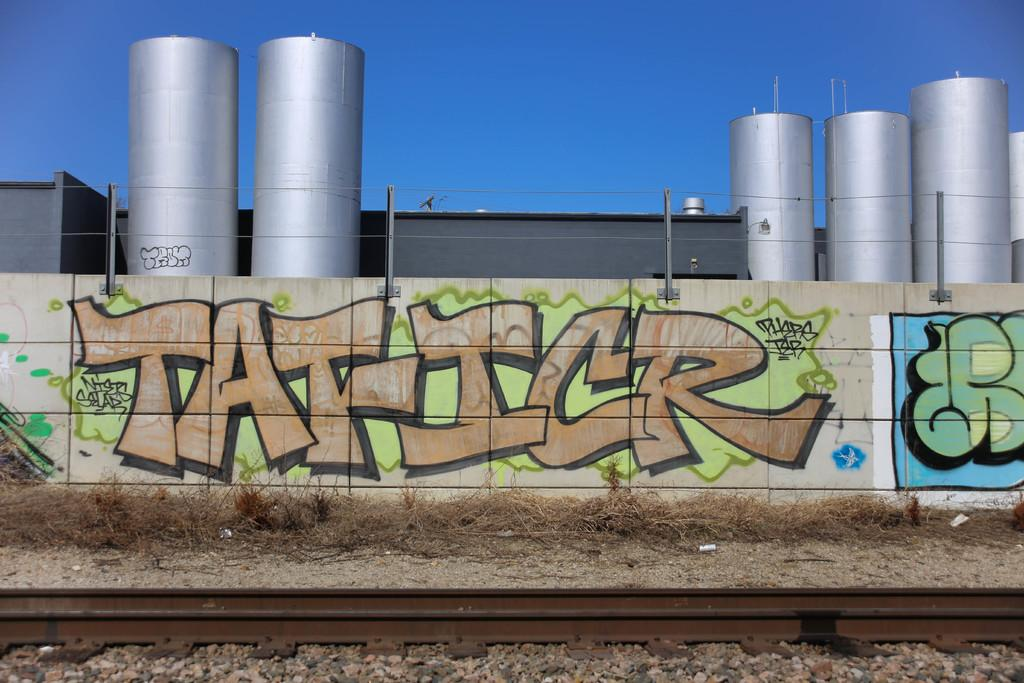Provide a one-sentence caption for the provided image. On the wall portion of the fence surrounding an industrial plant is graffiti with the word Taficr. 